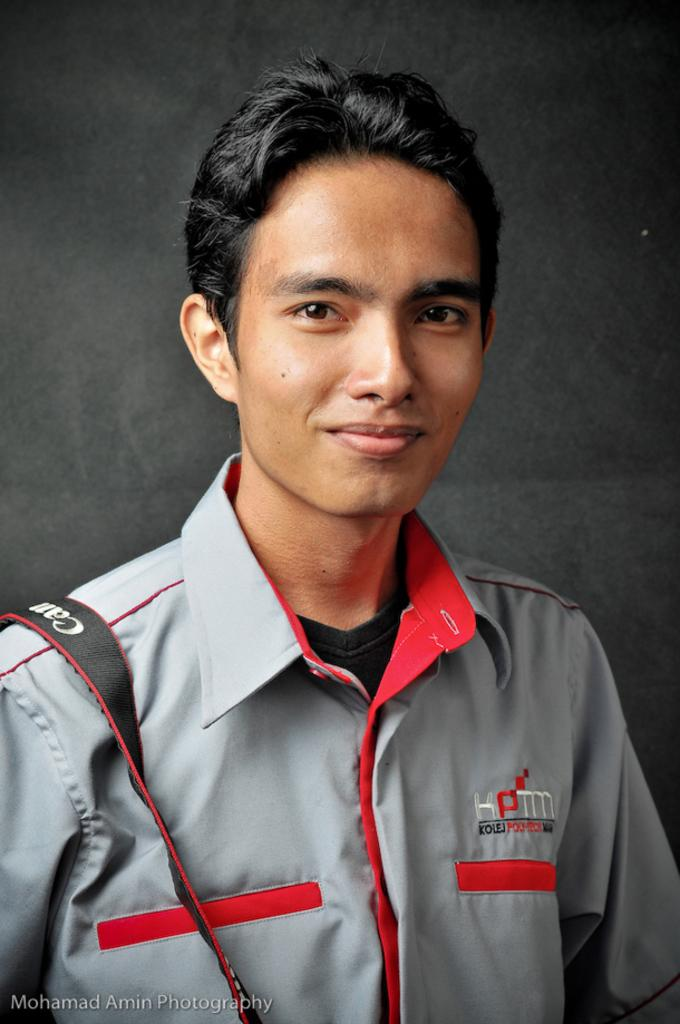Provide a one-sentence caption for the provided image. A man is wearing a grey and orange collared shirt with a Cannon Camera strap over his right shoulder. 